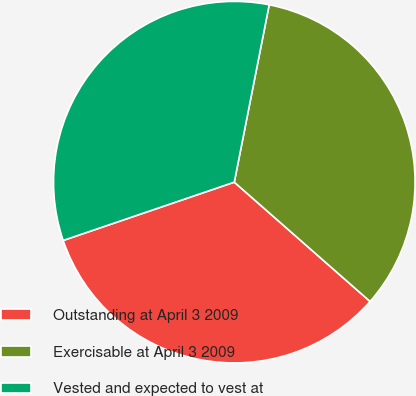Convert chart. <chart><loc_0><loc_0><loc_500><loc_500><pie_chart><fcel>Outstanding at April 3 2009<fcel>Exercisable at April 3 2009<fcel>Vested and expected to vest at<nl><fcel>33.3%<fcel>33.38%<fcel>33.32%<nl></chart> 